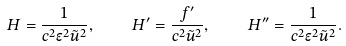Convert formula to latex. <formula><loc_0><loc_0><loc_500><loc_500>H = \frac { 1 } { c ^ { 2 } \epsilon ^ { 2 } \tilde { u } ^ { 2 } } , \quad H ^ { \prime } = \frac { f ^ { \prime } } { c ^ { 2 } \tilde { u } ^ { 2 } } , \quad H ^ { \prime \prime } = \frac { 1 } { c ^ { 2 } \epsilon ^ { 2 } \tilde { u } ^ { 2 } } .</formula> 